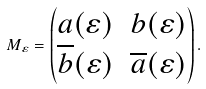Convert formula to latex. <formula><loc_0><loc_0><loc_500><loc_500>M _ { \varepsilon } = \begin{pmatrix} a ( \varepsilon ) & b ( \varepsilon ) \\ \overline { b } ( \varepsilon ) & \overline { a } ( \varepsilon ) \end{pmatrix} .</formula> 